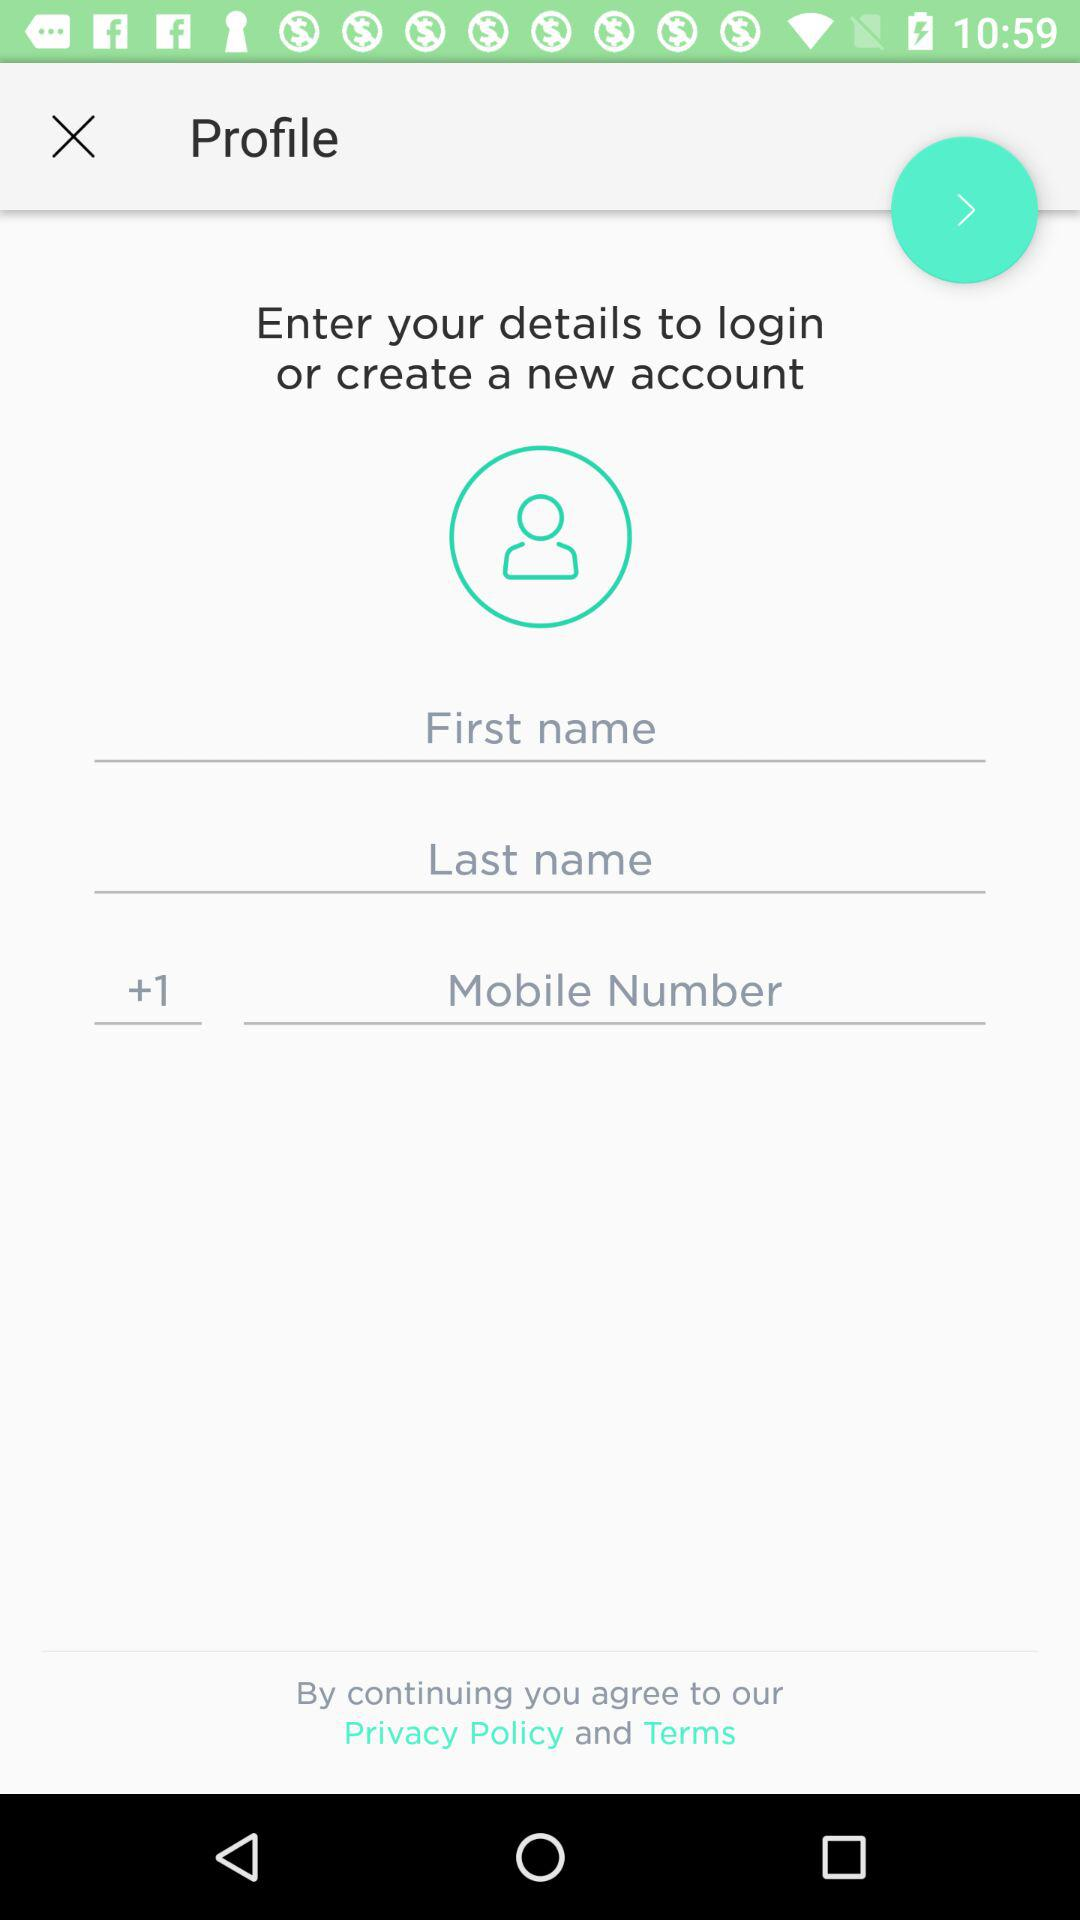How many text inputs are there for entering personal information?
Answer the question using a single word or phrase. 3 